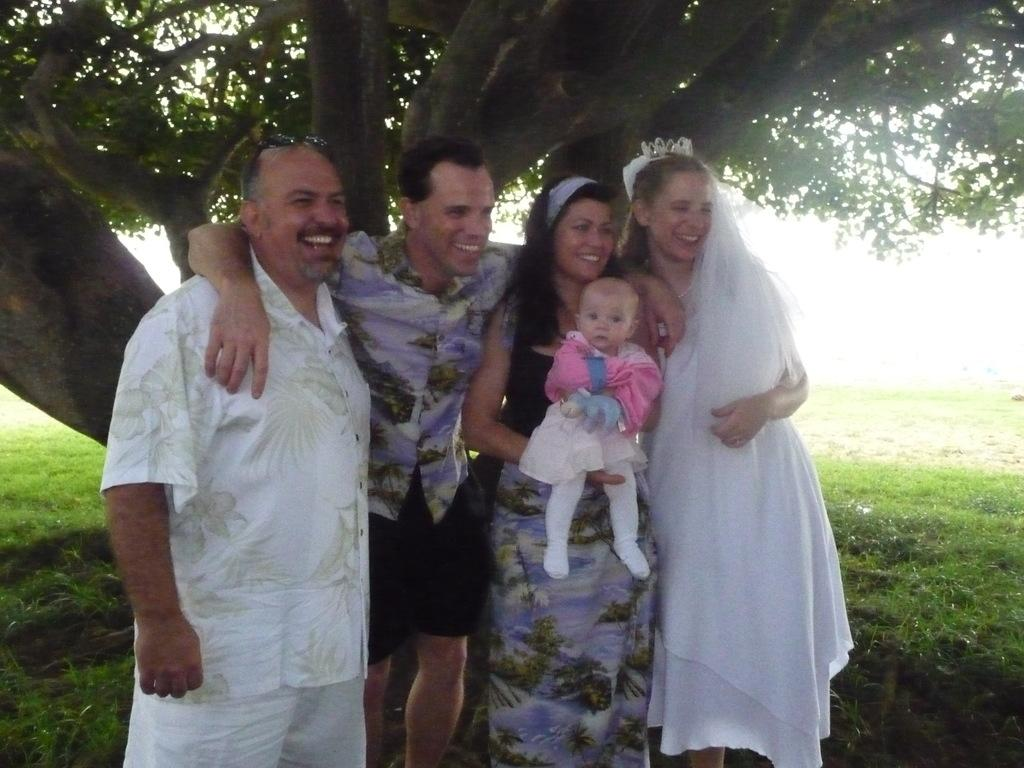How many people are in the image? There are four people in the image: two men and two women. What are the people in the image doing? The people are standing and smiling in the image. Can you describe the woman holding a baby? One woman is holding a baby in the image. What type of vegetation can be seen in the image? There is grass visible in the image, as well as a tree with branches and leaves. What type of pancake is being used as a hat in the image? There is no pancake present in the image, and no one is wearing a pancake as a hat. 